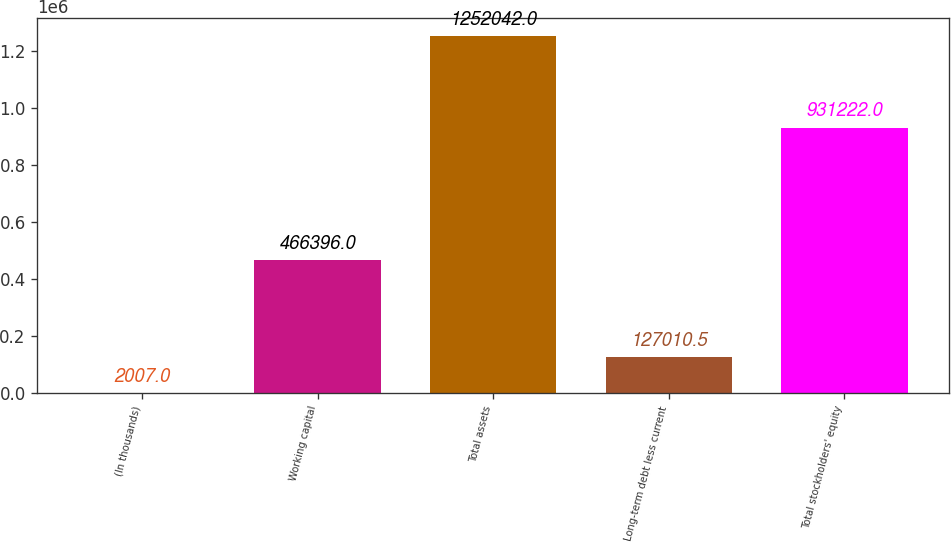Convert chart to OTSL. <chart><loc_0><loc_0><loc_500><loc_500><bar_chart><fcel>(In thousands)<fcel>Working capital<fcel>Total assets<fcel>Long-term debt less current<fcel>Total stockholders' equity<nl><fcel>2007<fcel>466396<fcel>1.25204e+06<fcel>127010<fcel>931222<nl></chart> 